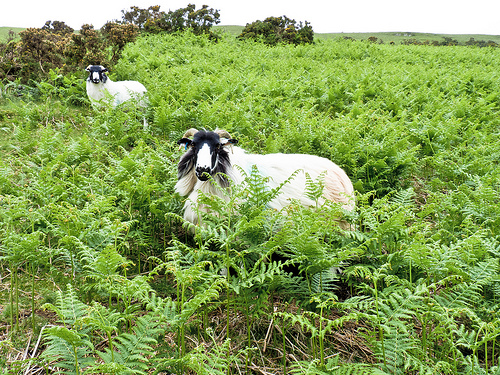Please provide a short description for this region: [0.19, 0.26, 0.31, 0.38]. The portion of the image shows a goat with dominantly white fur, scattered patches of dirt visible, giving an insight into the goat's roaming terrain. 